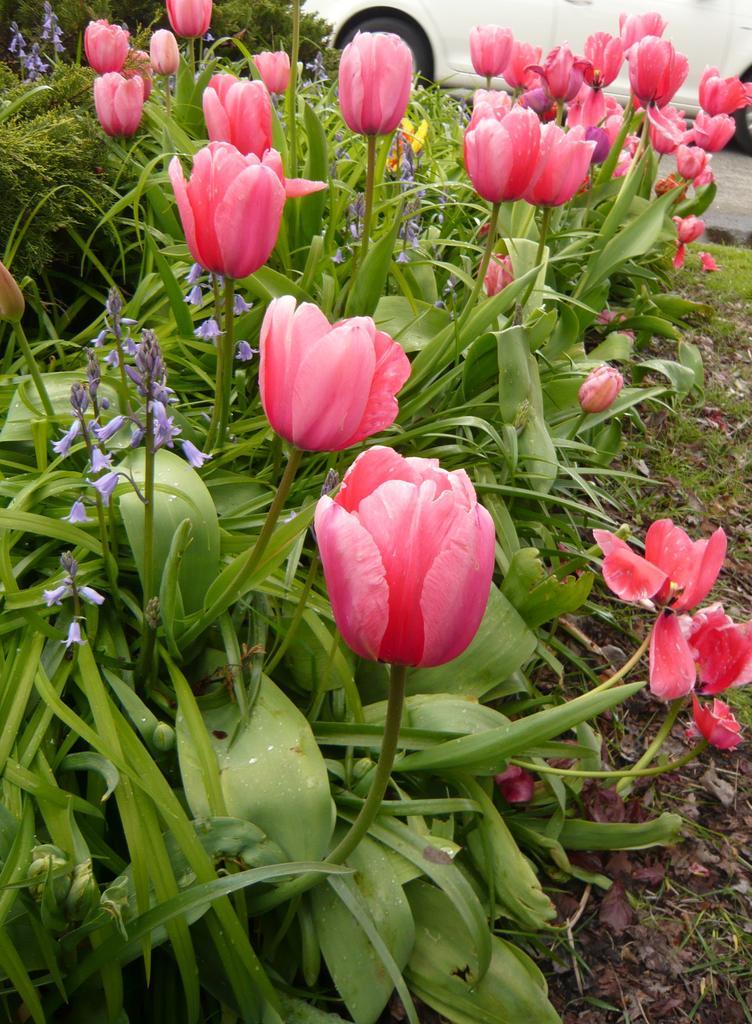In one or two sentences, can you explain what this image depicts? In this image I can see the flowers to the plants. In the background I can see the vehicle. 